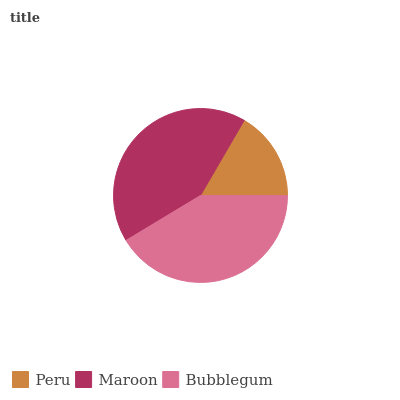Is Peru the minimum?
Answer yes or no. Yes. Is Maroon the maximum?
Answer yes or no. Yes. Is Bubblegum the minimum?
Answer yes or no. No. Is Bubblegum the maximum?
Answer yes or no. No. Is Maroon greater than Bubblegum?
Answer yes or no. Yes. Is Bubblegum less than Maroon?
Answer yes or no. Yes. Is Bubblegum greater than Maroon?
Answer yes or no. No. Is Maroon less than Bubblegum?
Answer yes or no. No. Is Bubblegum the high median?
Answer yes or no. Yes. Is Bubblegum the low median?
Answer yes or no. Yes. Is Peru the high median?
Answer yes or no. No. Is Peru the low median?
Answer yes or no. No. 